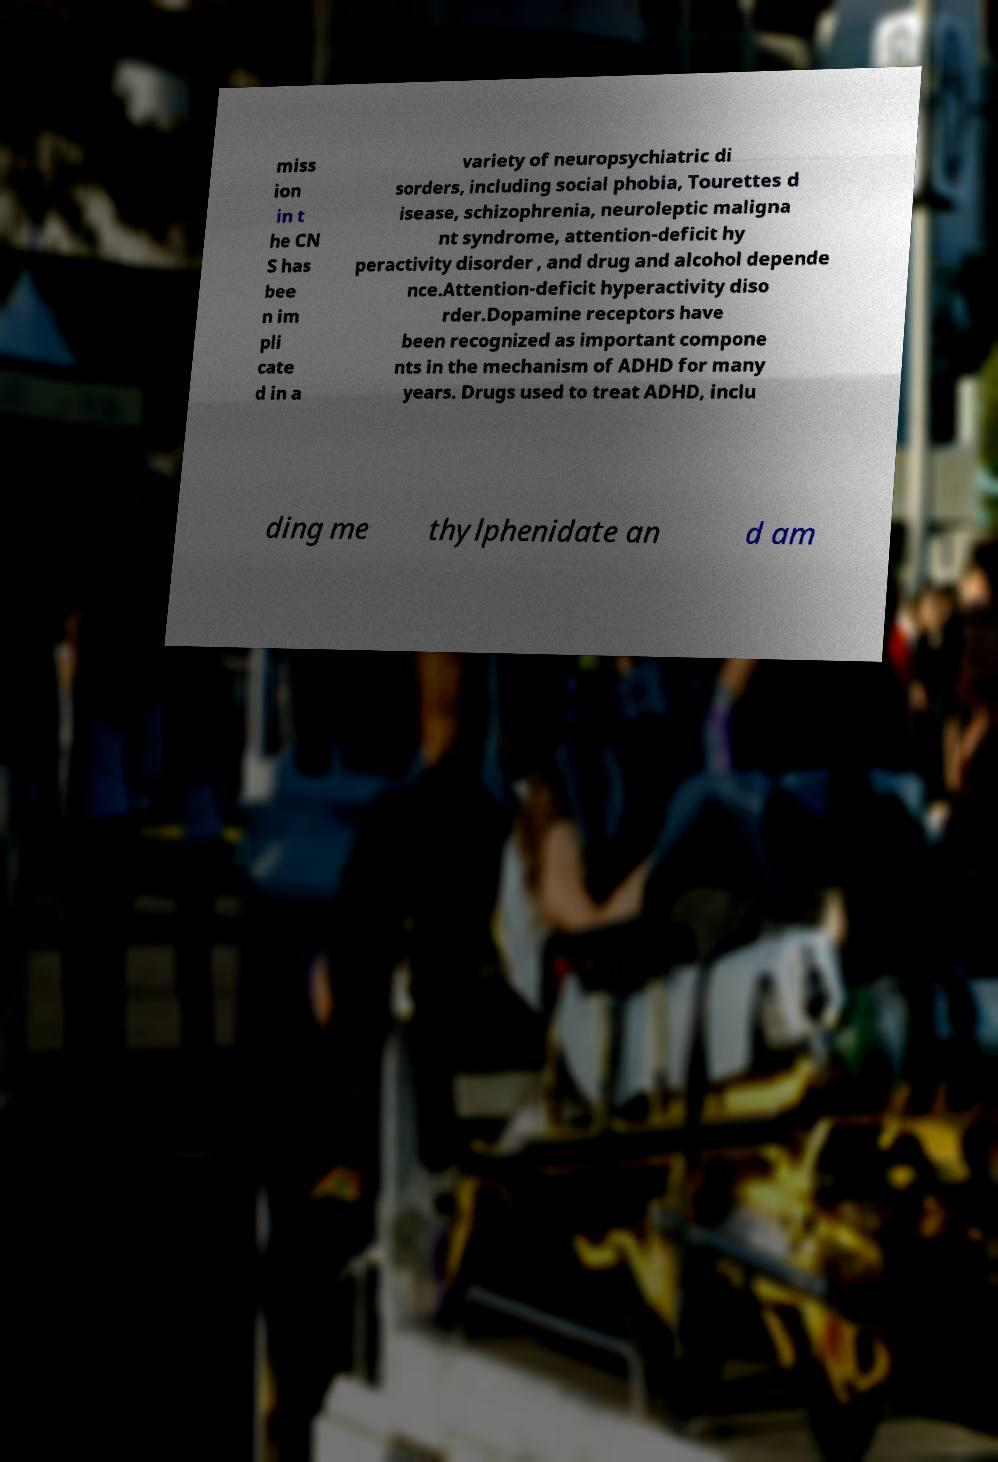Can you read and provide the text displayed in the image?This photo seems to have some interesting text. Can you extract and type it out for me? miss ion in t he CN S has bee n im pli cate d in a variety of neuropsychiatric di sorders, including social phobia, Tourettes d isease, schizophrenia, neuroleptic maligna nt syndrome, attention-deficit hy peractivity disorder , and drug and alcohol depende nce.Attention-deficit hyperactivity diso rder.Dopamine receptors have been recognized as important compone nts in the mechanism of ADHD for many years. Drugs used to treat ADHD, inclu ding me thylphenidate an d am 